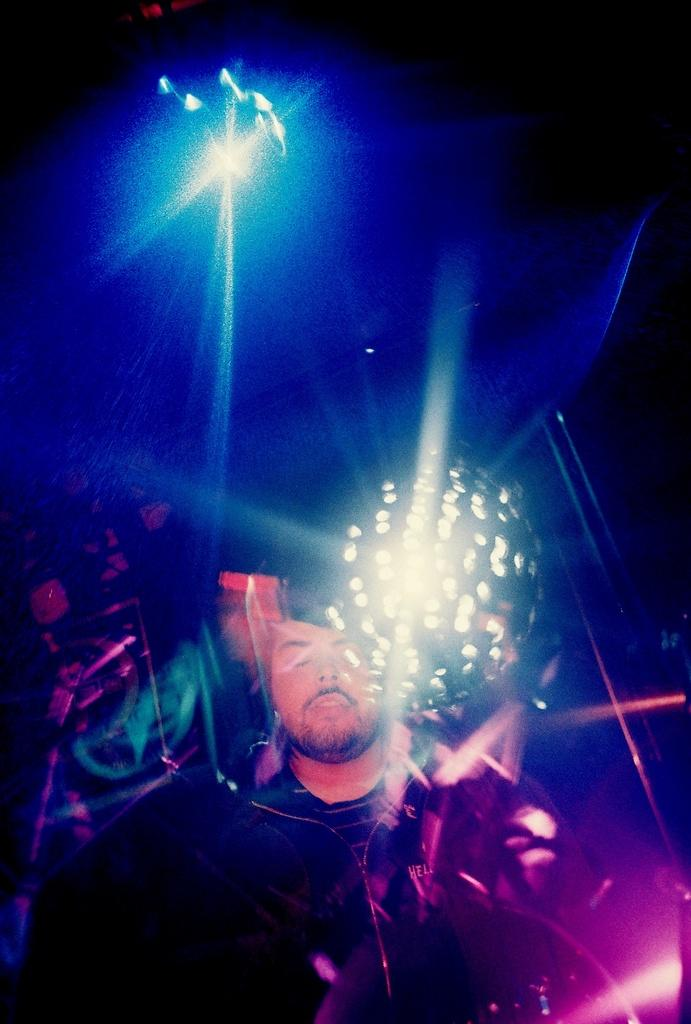What is present in the image? There is a person in the image. What can be seen in the background of the image? There are colorful lights in the background of the image. What type of adjustment does the person need to make to their guitar in the image? There is no guitar present in the image, so no adjustment is necessary. 